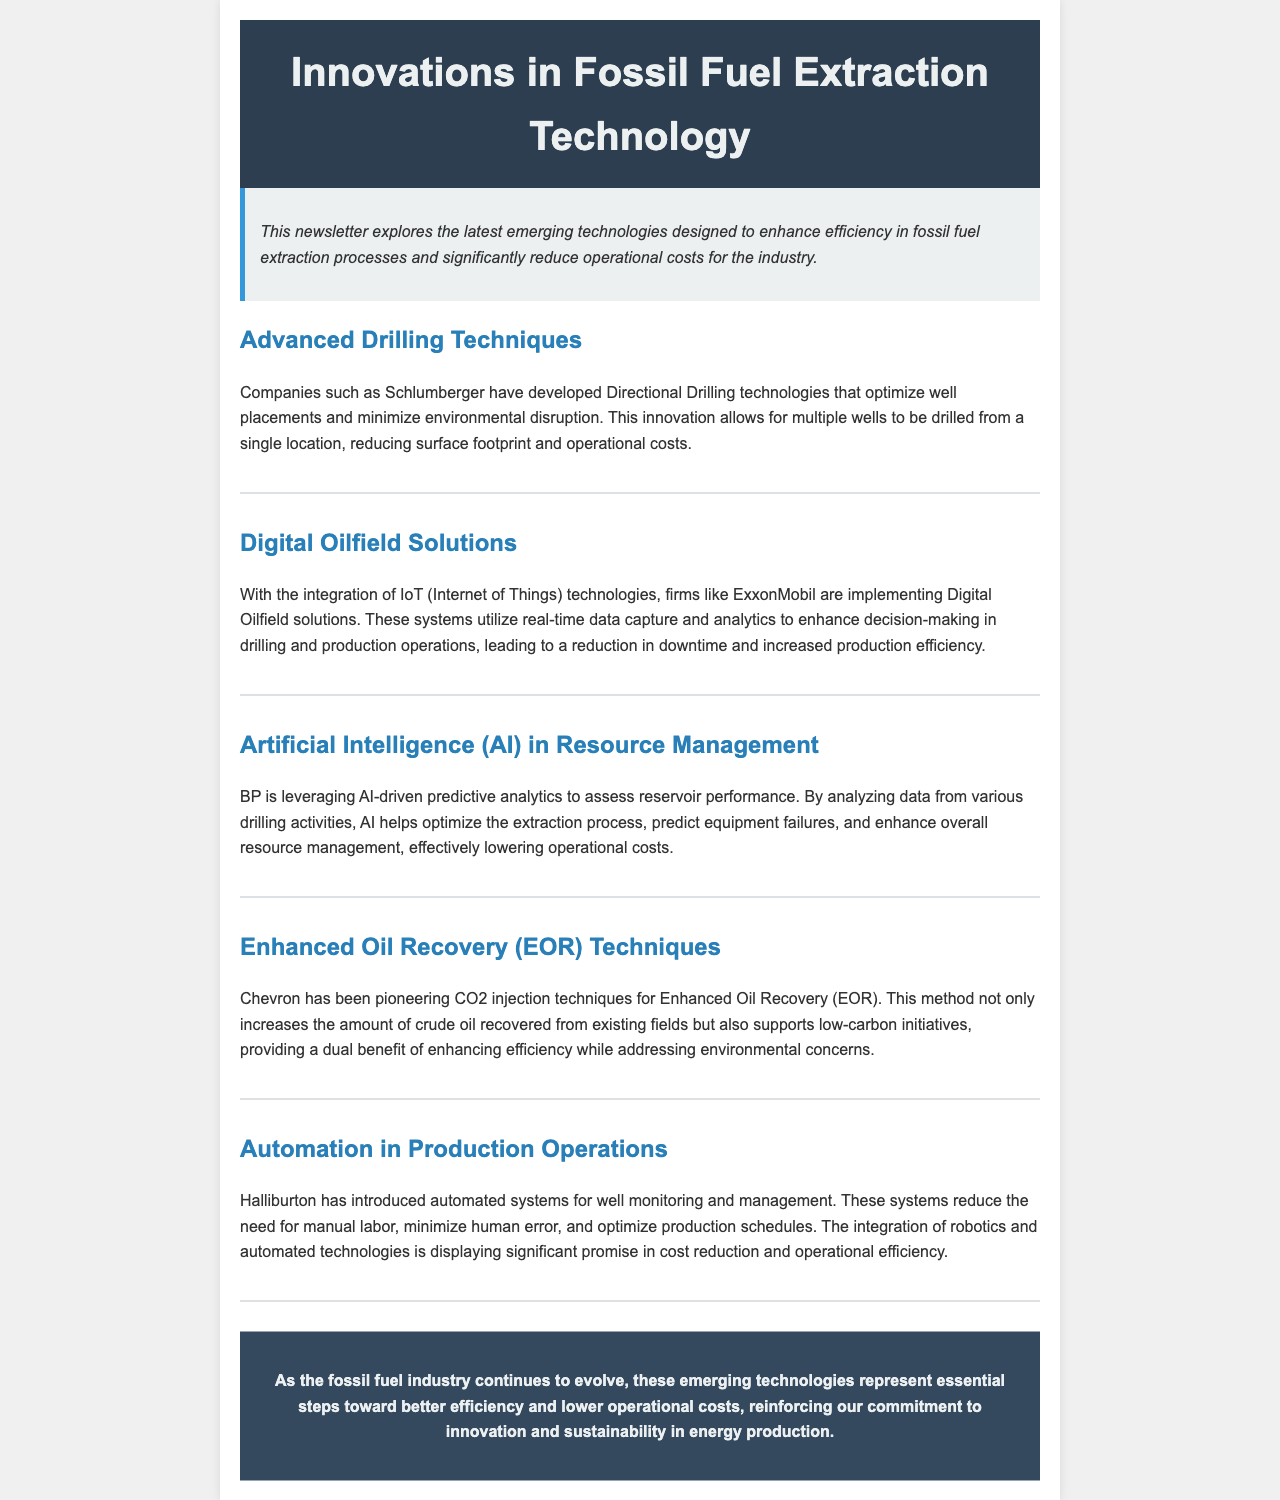What company developed Directional Drilling technologies? The document states that Schlumberger has developed Directional Drilling technologies.
Answer: Schlumberger What technique does Chevron pioneer for Enhanced Oil Recovery? The document specifies that Chevron has been pioneering CO2 injection techniques for Enhanced Oil Recovery.
Answer: CO2 injection techniques Which company is implementing Digital Oilfield solutions? The document mentions that ExxonMobil is implementing Digital Oilfield solutions.
Answer: ExxonMobil What is one benefit of AI-driven predictive analytics mentioned for BP? The document highlights that AI helps optimize the extraction process as one benefit.
Answer: Optimize the extraction process What is the primary focus of Halliburton's automated systems? The document states that these systems aim to reduce the need for manual labor.
Answer: Reduce the need for manual labor Which technology is said to enhance decision-making in drilling operations? The document notes that Digital Oilfield solutions utilize real-time data capture and analytics for decision-making.
Answer: Digital Oilfield solutions What dual benefit does Chevron's CO2 injection technique provide? The document points out that it enhances efficiency while addressing environmental concerns.
Answer: Enhancing efficiency and addressing environmental concerns Which company utilizes IoT technologies according to the document? The document states that ExxonMobil is utilizing IoT technologies.
Answer: ExxonMobil What is the overarching theme of the newsletter? The document specifies that the newsletter explores emerging technologies enhancing efficiency and reducing operational costs.
Answer: Emerging technologies enhancing efficiency and reducing operational costs 